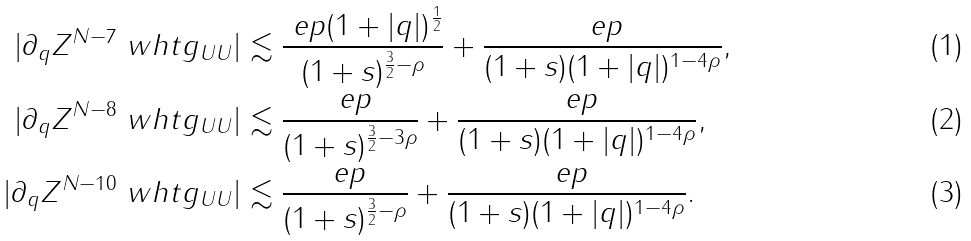Convert formula to latex. <formula><loc_0><loc_0><loc_500><loc_500>| \partial _ { q } Z ^ { N - 7 } \ w h t g _ { U U } | & \lesssim \frac { \ e p ( 1 + | q | ) ^ { \frac { 1 } { 2 } } } { ( 1 + s ) ^ { \frac { 3 } { 2 } - \rho } } + \frac { \ e p } { ( 1 + s ) ( 1 + | q | ) ^ { 1 - 4 \rho } } , \\ | \partial _ { q } Z ^ { N - 8 } \ w h t g _ { U U } | & \lesssim \frac { \ e p } { ( 1 + s ) ^ { \frac { 3 } { 2 } - 3 \rho } } + \frac { \ e p } { ( 1 + s ) ( 1 + | q | ) ^ { 1 - 4 \rho } } , \\ | \partial _ { q } Z ^ { N - 1 0 } \ w h t g _ { U U } | & \lesssim \frac { \ e p } { ( 1 + s ) ^ { \frac { 3 } { 2 } - \rho } } + \frac { \ e p } { ( 1 + s ) ( 1 + | q | ) ^ { 1 - 4 \rho } } .</formula> 